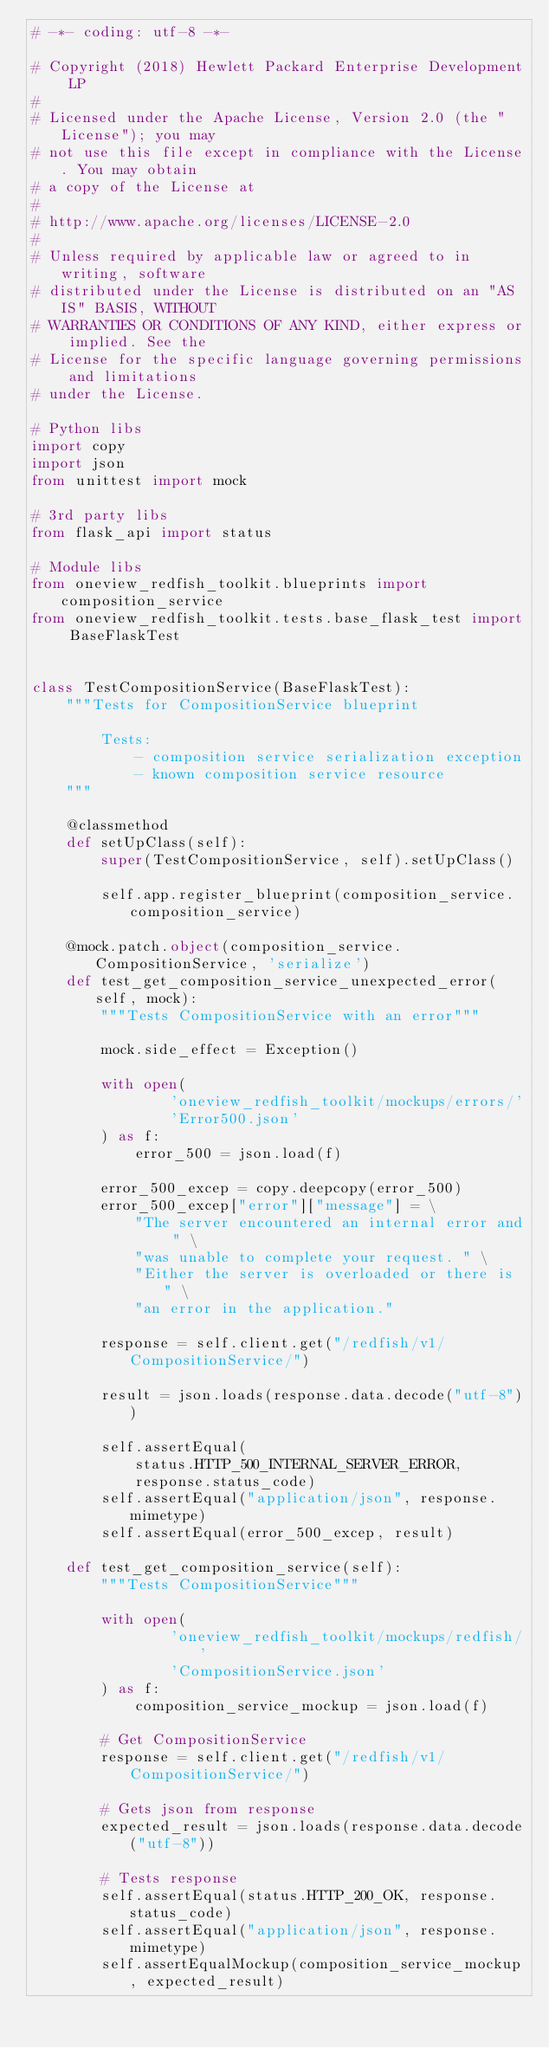<code> <loc_0><loc_0><loc_500><loc_500><_Python_># -*- coding: utf-8 -*-

# Copyright (2018) Hewlett Packard Enterprise Development LP
#
# Licensed under the Apache License, Version 2.0 (the "License"); you may
# not use this file except in compliance with the License. You may obtain
# a copy of the License at
#
# http://www.apache.org/licenses/LICENSE-2.0
#
# Unless required by applicable law or agreed to in writing, software
# distributed under the License is distributed on an "AS IS" BASIS, WITHOUT
# WARRANTIES OR CONDITIONS OF ANY KIND, either express or implied. See the
# License for the specific language governing permissions and limitations
# under the License.

# Python libs
import copy
import json
from unittest import mock

# 3rd party libs
from flask_api import status

# Module libs
from oneview_redfish_toolkit.blueprints import composition_service
from oneview_redfish_toolkit.tests.base_flask_test import BaseFlaskTest


class TestCompositionService(BaseFlaskTest):
    """Tests for CompositionService blueprint

        Tests:
            - composition service serialization exception
            - known composition service resource
    """

    @classmethod
    def setUpClass(self):
        super(TestCompositionService, self).setUpClass()

        self.app.register_blueprint(composition_service.composition_service)

    @mock.patch.object(composition_service.CompositionService, 'serialize')
    def test_get_composition_service_unexpected_error(self, mock):
        """Tests CompositionService with an error"""

        mock.side_effect = Exception()

        with open(
                'oneview_redfish_toolkit/mockups/errors/'
                'Error500.json'
        ) as f:
            error_500 = json.load(f)

        error_500_excep = copy.deepcopy(error_500)
        error_500_excep["error"]["message"] = \
            "The server encountered an internal error and " \
            "was unable to complete your request. " \
            "Either the server is overloaded or there is " \
            "an error in the application."

        response = self.client.get("/redfish/v1/CompositionService/")

        result = json.loads(response.data.decode("utf-8"))

        self.assertEqual(
            status.HTTP_500_INTERNAL_SERVER_ERROR,
            response.status_code)
        self.assertEqual("application/json", response.mimetype)
        self.assertEqual(error_500_excep, result)

    def test_get_composition_service(self):
        """Tests CompositionService"""

        with open(
                'oneview_redfish_toolkit/mockups/redfish/'
                'CompositionService.json'
        ) as f:
            composition_service_mockup = json.load(f)

        # Get CompositionService
        response = self.client.get("/redfish/v1/CompositionService/")

        # Gets json from response
        expected_result = json.loads(response.data.decode("utf-8"))

        # Tests response
        self.assertEqual(status.HTTP_200_OK, response.status_code)
        self.assertEqual("application/json", response.mimetype)
        self.assertEqualMockup(composition_service_mockup, expected_result)
</code> 